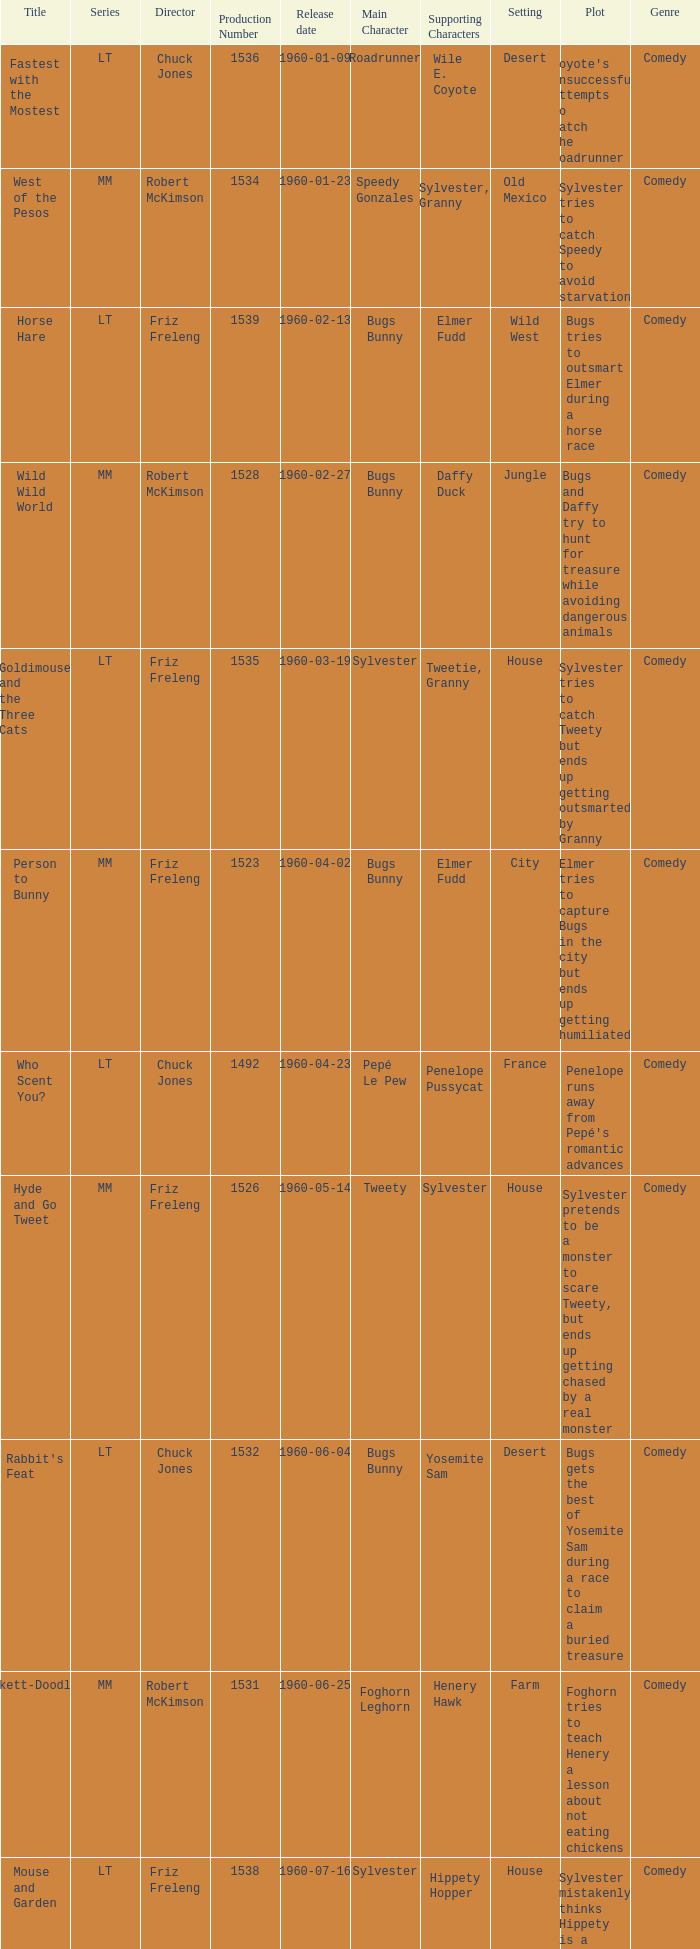What is the Series number of the episode with a production number of 1547? MM. 